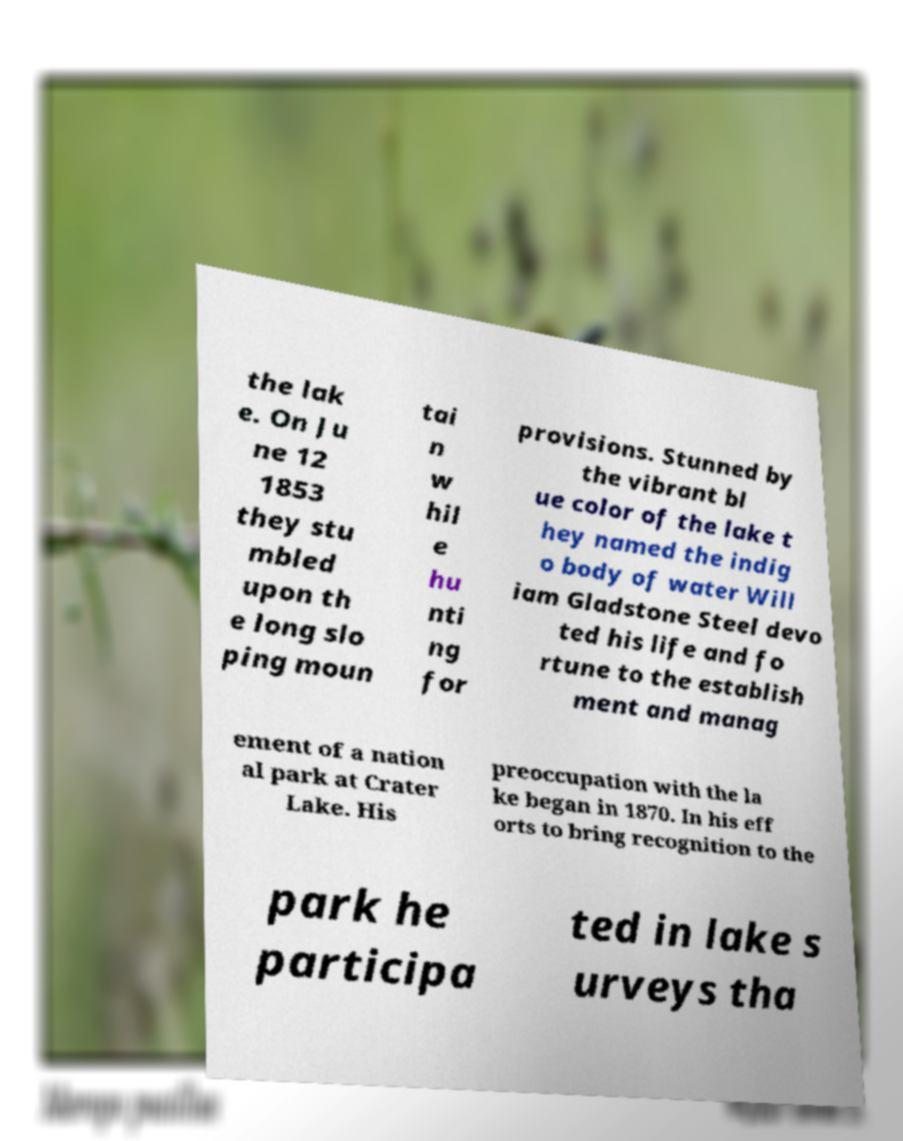Could you extract and type out the text from this image? the lak e. On Ju ne 12 1853 they stu mbled upon th e long slo ping moun tai n w hil e hu nti ng for provisions. Stunned by the vibrant bl ue color of the lake t hey named the indig o body of water Will iam Gladstone Steel devo ted his life and fo rtune to the establish ment and manag ement of a nation al park at Crater Lake. His preoccupation with the la ke began in 1870. In his eff orts to bring recognition to the park he participa ted in lake s urveys tha 